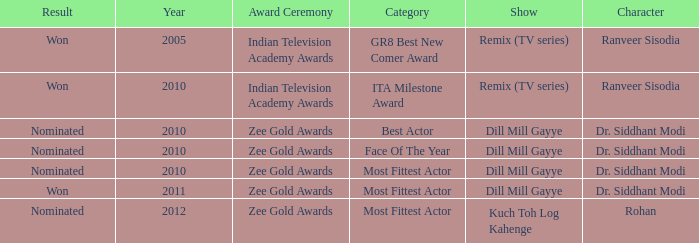Which show has a character of Rohan? Kuch Toh Log Kahenge. 